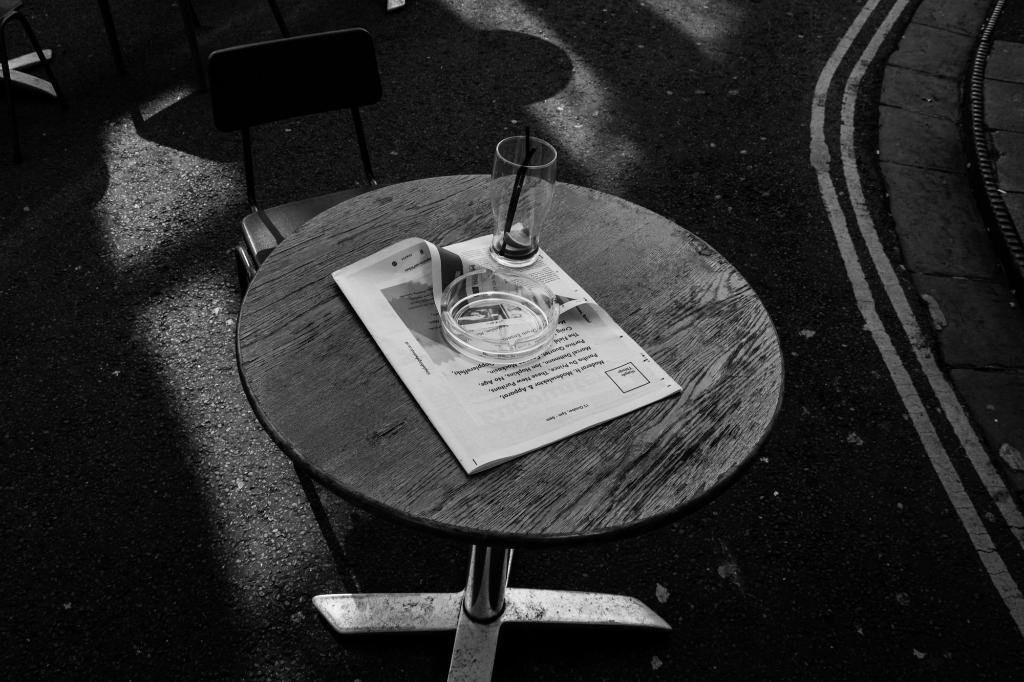What type of furniture is visible in the image? There are chairs and tables in the image. What is placed on the tables? Papers, a bowl, and a glass are present on the tables. Can you describe the background of the image? There is a fence in the background of the image. Where might this image have been taken? The image may have been taken on a road. What type of flowers can be seen growing along the trail in the image? There is no trail or flowers present in the image. 